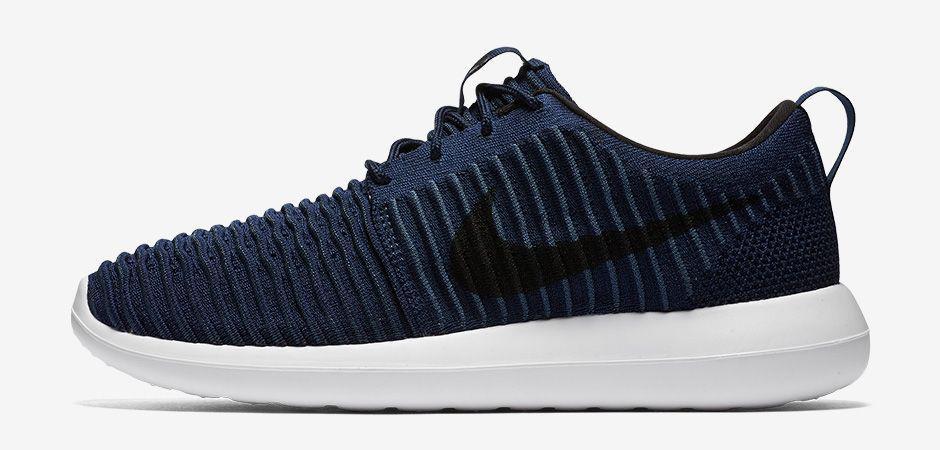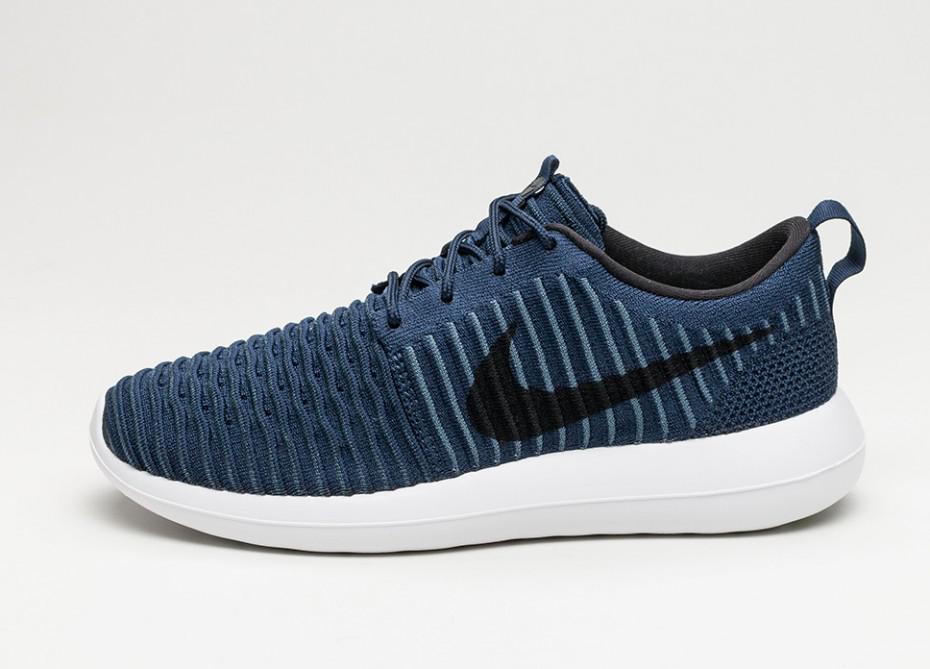The first image is the image on the left, the second image is the image on the right. For the images shown, is this caption "There are two shoes, and one of them is striped, while the other is a plain color." true? Answer yes or no. No. The first image is the image on the left, the second image is the image on the right. Considering the images on both sides, is "The combined images show exactly two left-facing sneakers." valid? Answer yes or no. Yes. 